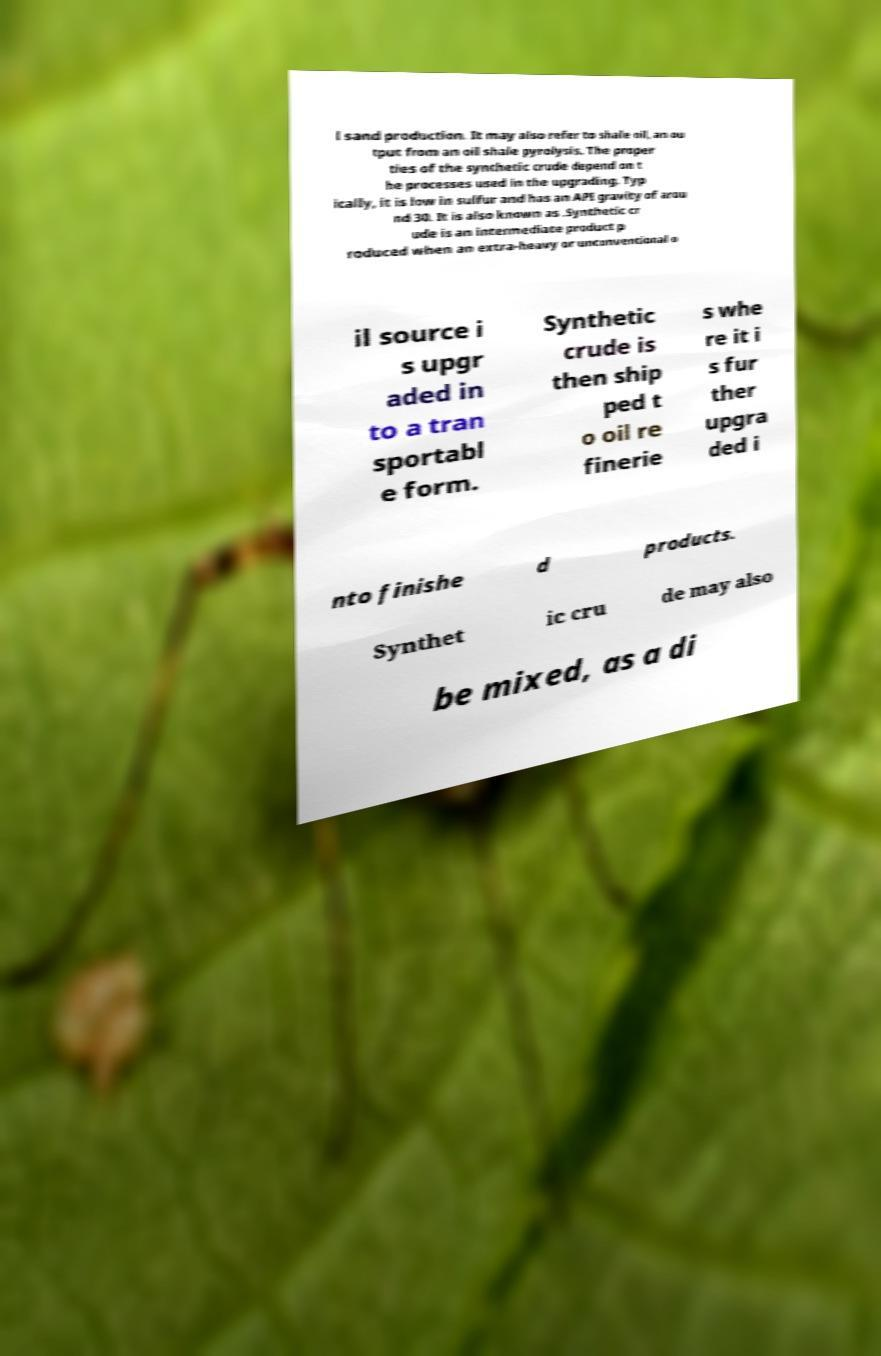I need the written content from this picture converted into text. Can you do that? l sand production. It may also refer to shale oil, an ou tput from an oil shale pyrolysis. The proper ties of the synthetic crude depend on t he processes used in the upgrading. Typ ically, it is low in sulfur and has an API gravity of arou nd 30. It is also known as .Synthetic cr ude is an intermediate product p roduced when an extra-heavy or unconventional o il source i s upgr aded in to a tran sportabl e form. Synthetic crude is then ship ped t o oil re finerie s whe re it i s fur ther upgra ded i nto finishe d products. Synthet ic cru de may also be mixed, as a di 